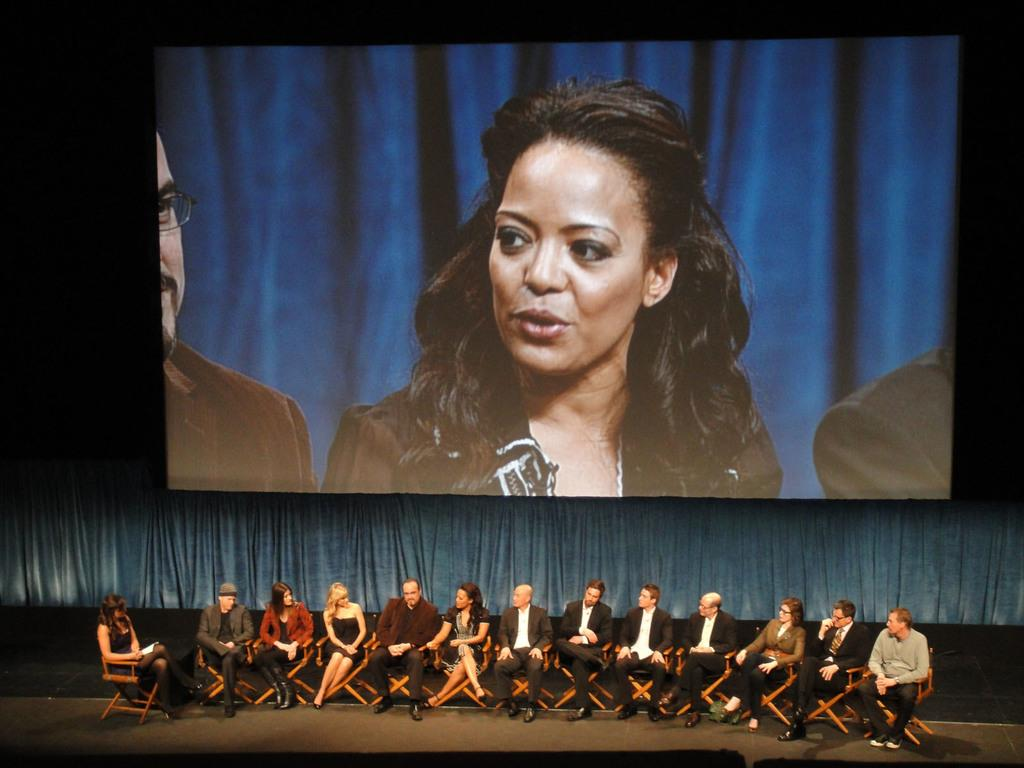What are the people in the image doing? The persons in the image are sitting on chairs. What can be seen on the screen in the image? The screen displays a picture of a woman and two persons. What is located behind the screen in the image? There is a curtain behind the screen. What type of game is being played on the chair in the image? There is no game being played in the image; the persons are simply sitting on chairs. How does the chair drop in the image? The chair does not drop in the image; it is stationary and being used for sitting. 